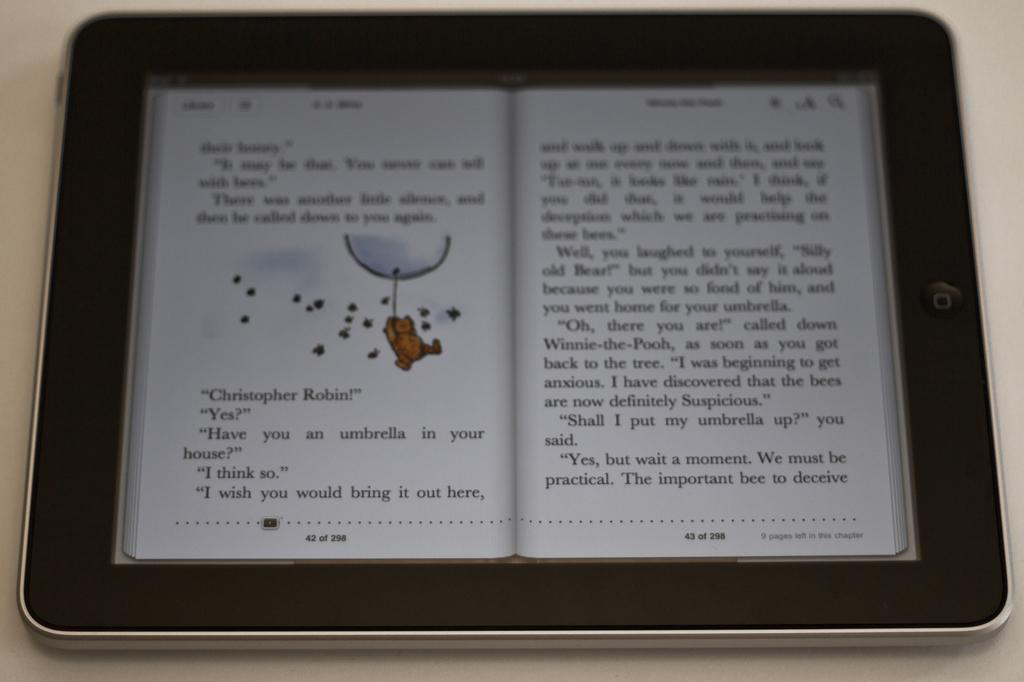Provide a one-sentence caption for the provided image. A kindle with an open edition of Winnie the Pooh with the first words being 'their honey'. 